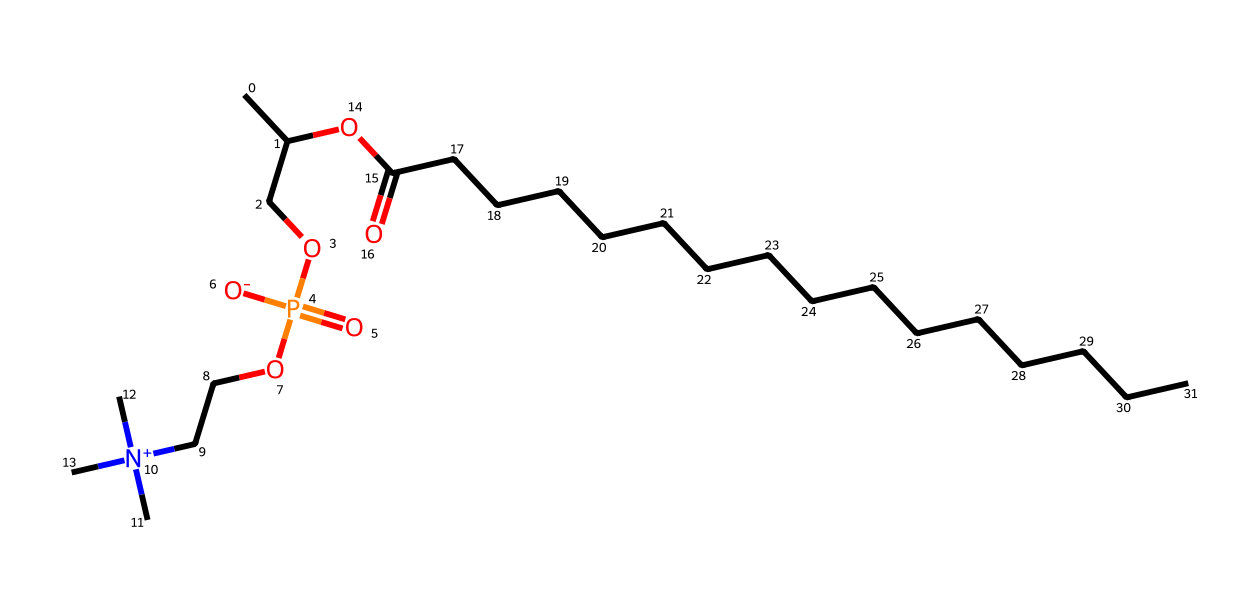What is the primary functional group present in lecithin? The structure shows the presence of a phosphate group (PO4), which features prominently in phospholipids like lecithin. This indicates that lecithin is a phospholipid.
Answer: phosphate How many carbon atoms are present in lecithin? By counting the carbon (C) atoms in the molecule, including both the fatty acid chain and the alkyl group, we find that there are 23 carbon atoms in total.
Answer: 23 What type of molecule is lecithin classified as? Lecithin has both hydrophobic (the long carbon chain) and hydrophilic (the phosphate and amino groups) components, classifying it as an amphiphilic molecule, typical for surfactants.
Answer: amphiphilic What is the role of lecithin in food emulsification? Lecithin acts as an emulsifier due to its amphiphilic nature, enabling it to reduce surface tension between oil and water, helping to stabilize emulsions in food products.
Answer: emulsifier How many nitrogen atoms are found in lecithin? The molecular structure contains one nitrogen atom present due to the quaternary ammonium center, which is typical in phospholipids like lecithin.
Answer: 1 What aspect of lecithin contributes to its surfactant properties? The presence of both hydrophobic tails (fatty acid chains) and a hydrophilic head (phosphate group) allows lecithin to lower surface tension between immiscible liquids, which is essential for surfactant function.
Answer: hydrophobic and hydrophilic parts 